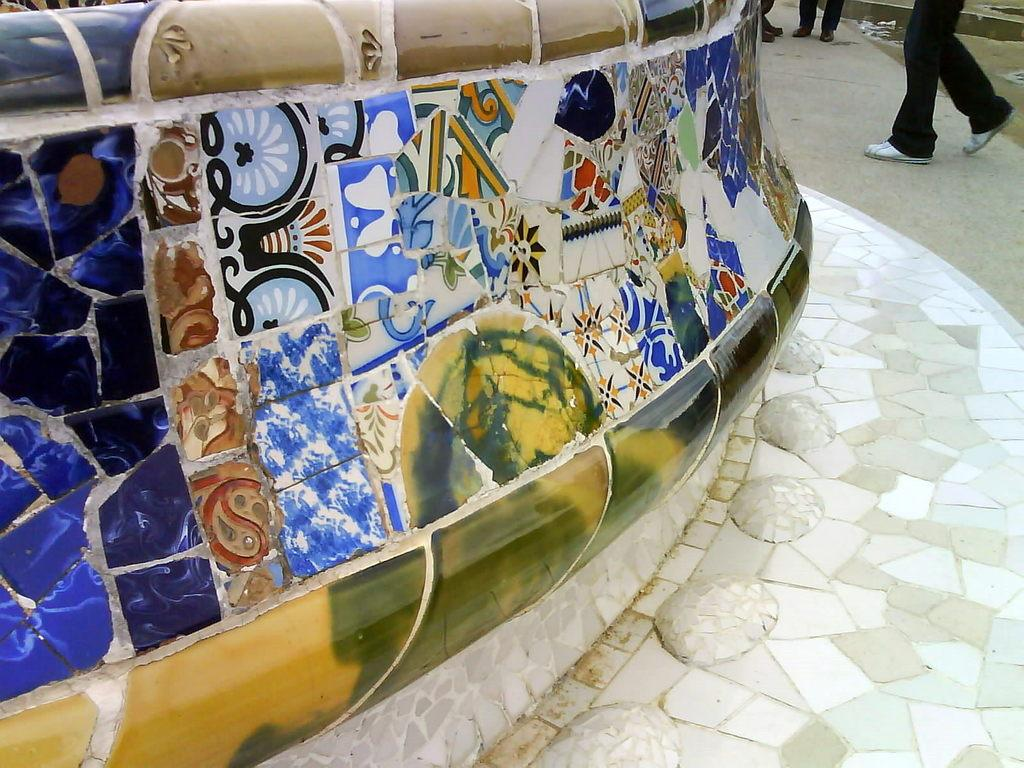What is located on the left side of the image? There is a wall on the left side of the image. What is attached to the wall? There are marbles on the wall. Where are the persons in the image situated? The persons are on the ground in the image. What letters are the persons on the ground trying to spell with the straw? There is no straw or letters present in the image. 